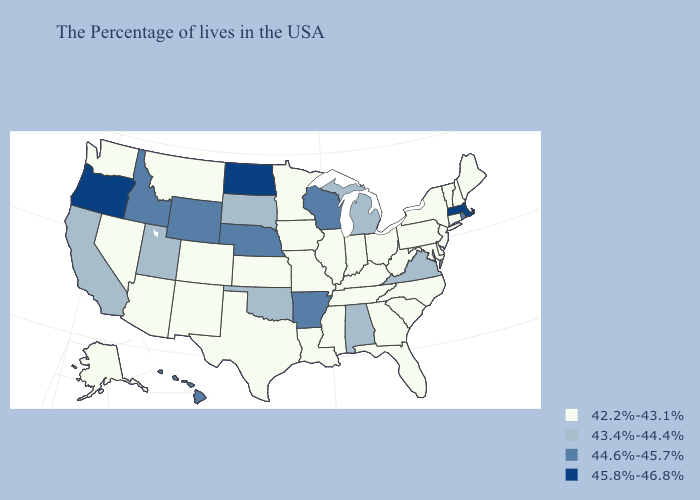Among the states that border Utah , which have the highest value?
Short answer required. Wyoming, Idaho. Does the map have missing data?
Answer briefly. No. Does Michigan have a lower value than Missouri?
Write a very short answer. No. What is the value of Louisiana?
Give a very brief answer. 42.2%-43.1%. Does Iowa have a lower value than Arkansas?
Be succinct. Yes. What is the highest value in states that border Louisiana?
Quick response, please. 44.6%-45.7%. Does California have a lower value than Wyoming?
Answer briefly. Yes. Name the states that have a value in the range 44.6%-45.7%?
Be succinct. Rhode Island, Wisconsin, Arkansas, Nebraska, Wyoming, Idaho, Hawaii. What is the highest value in the South ?
Short answer required. 44.6%-45.7%. What is the value of Michigan?
Be succinct. 43.4%-44.4%. Among the states that border Louisiana , does Arkansas have the highest value?
Give a very brief answer. Yes. What is the highest value in the Northeast ?
Be succinct. 45.8%-46.8%. Name the states that have a value in the range 43.4%-44.4%?
Quick response, please. Virginia, Michigan, Alabama, Oklahoma, South Dakota, Utah, California. Does Illinois have the lowest value in the MidWest?
Write a very short answer. Yes. What is the value of Texas?
Quick response, please. 42.2%-43.1%. 